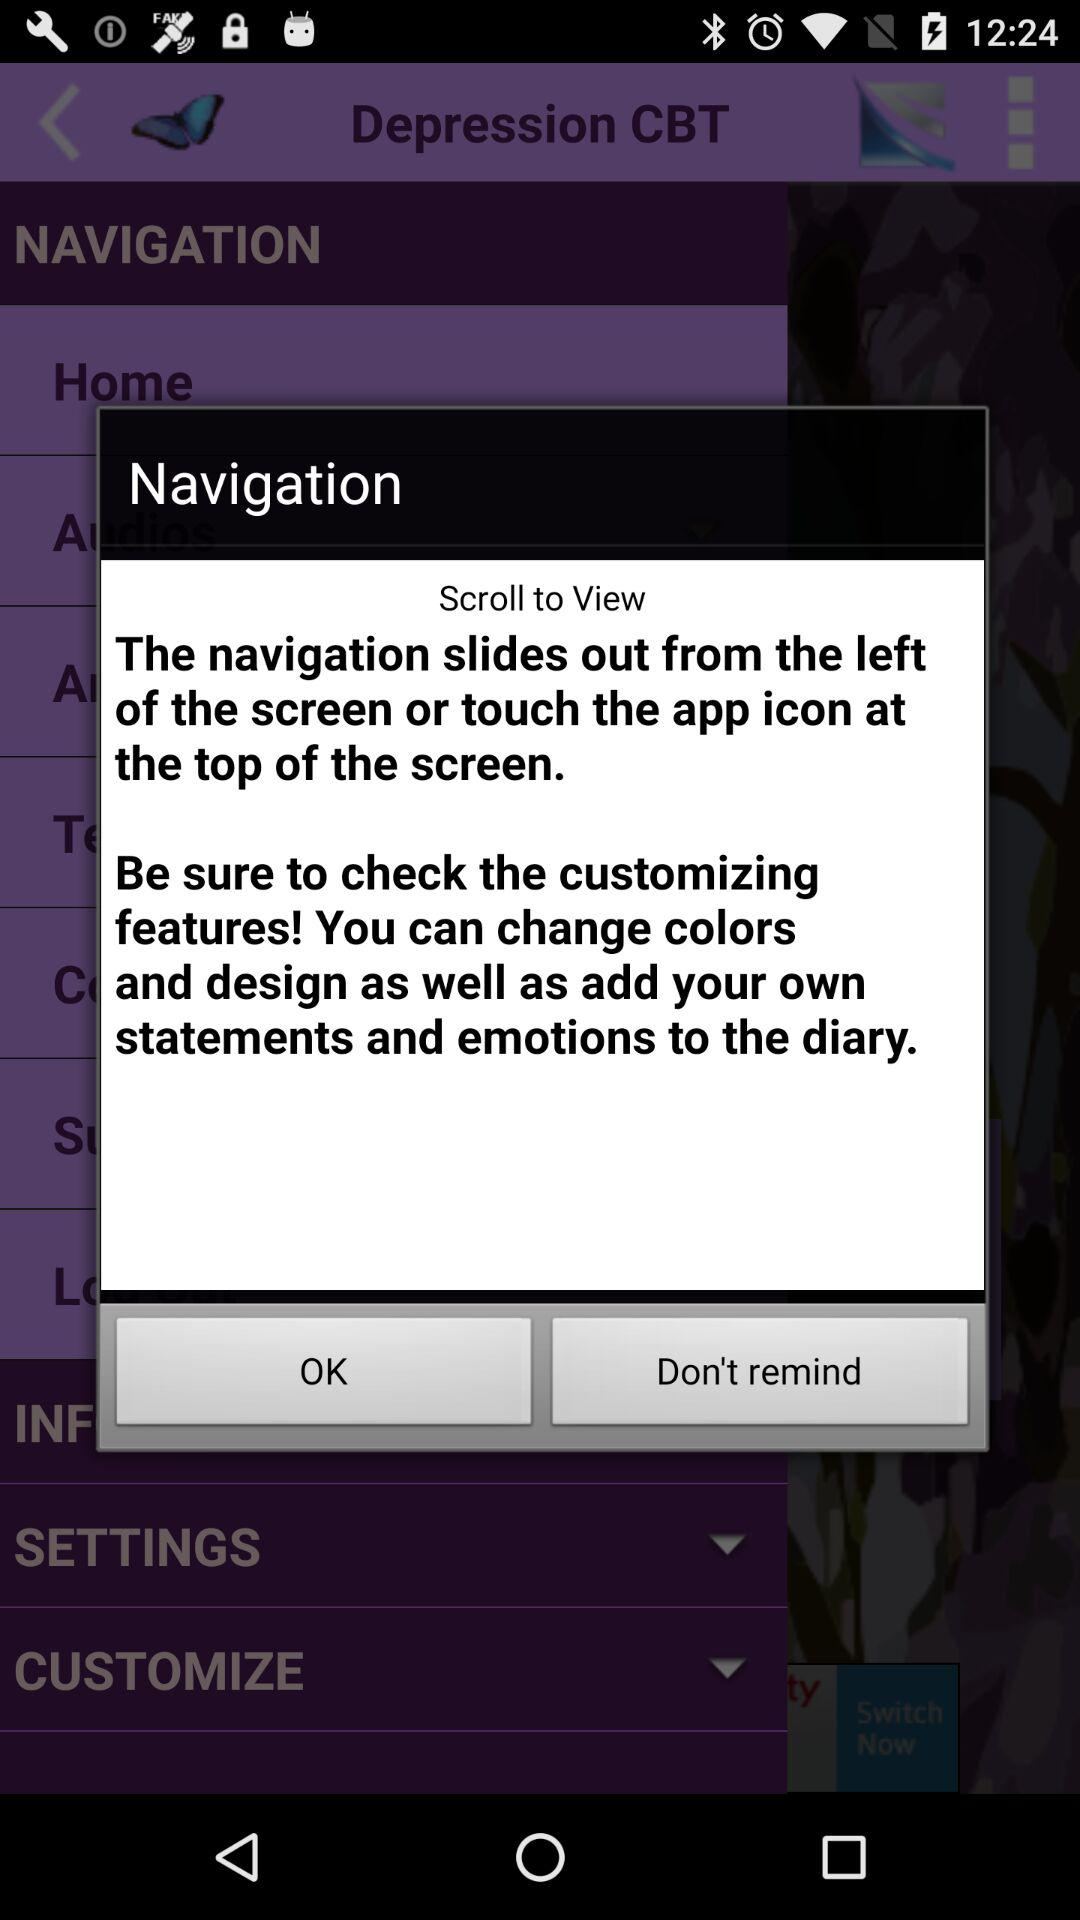How do I navigate? You can use the navigation slides to the left of the screen or touch the app icon at the top of the screen to navigate. 